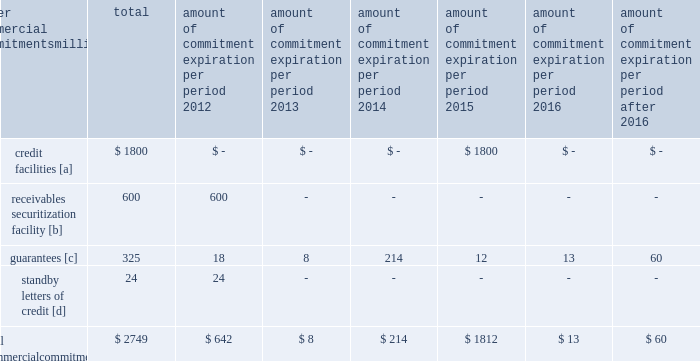Amount of commitment expiration per period other commercial commitments after millions total 2012 2013 2014 2015 2016 2016 .
[a] none of the credit facility was used as of december 31 , 2011 .
[b] $ 100 million of the receivables securitization facility was utilized at december 31 , 2011 , which is accounted for as debt .
The full program matures in august 2012 .
[c] includes guaranteed obligations related to our headquarters building , equipment financings , and affiliated operations .
[d] none of the letters of credit were drawn upon as of december 31 , 2011 .
Off-balance sheet arrangements guarantees 2013 at december 31 , 2011 , we were contingently liable for $ 325 million in guarantees .
We have recorded a liability of $ 3 million for the fair value of these obligations as of december 31 , 2011 and 2010 .
We entered into these contingent guarantees in the normal course of business , and they include guaranteed obligations related to our headquarters building , equipment financings , and affiliated operations .
The final guarantee expires in 2022 .
We are not aware of any existing event of default that would require us to satisfy these guarantees .
We do not expect that these guarantees will have a material adverse effect on our consolidated financial condition , results of operations , or liquidity .
Other matters labor agreements 2013 in january 2010 , the nation 2019s largest freight railroads began the current round of negotiations with the labor unions .
Generally , contract negotiations with the various unions take place over an extended period of time .
This round of negotiations was no exception .
In september 2011 , the rail industry reached agreements with the united transportation union .
On november 5 , 2011 , a presidential emergency board ( peb ) appointed by president obama issued recommendations to resolve the disputes between the u.s .
Railroads and 11 unions that had not yet reached agreements .
Since then , ten unions reached agreements with the railroads , all of them generally patterned on the recommendations of the peb , and the unions subsequently ratified these agreements .
The railroad industry reached a tentative agreement with the brotherhood of maintenance of way employees ( bmwe ) on february 2 , 2012 , eliminating the immediate threat of a national rail strike .
The bmwe now will commence ratification of this tentative agreement by its members .
Inflation 2013 long periods of inflation significantly increase asset replacement costs for capital-intensive companies .
As a result , assuming that we replace all operating assets at current price levels , depreciation charges ( on an inflation-adjusted basis ) would be substantially greater than historically reported amounts .
Derivative financial instruments 2013 we may use derivative financial instruments in limited instances to assist in managing our overall exposure to fluctuations in interest rates and fuel prices .
We are not a party to leveraged derivatives and , by policy , do not use derivative financial instruments for speculative purposes .
Derivative financial instruments qualifying for hedge accounting must maintain a specified level of effectiveness between the hedging instrument and the item being hedged , both at inception and throughout the hedged period .
We formally document the nature and relationships between the hedging instruments and hedged items at inception , as well as our risk-management objectives , strategies for undertaking the various hedge transactions , and method of assessing hedge effectiveness .
Changes in the fair market value of derivative financial instruments that do not qualify for hedge accounting are charged to earnings .
We may use swaps , collars , futures , and/or forward contracts to mitigate the risk of adverse movements in interest rates and fuel prices ; however , the use of these derivative financial instruments may limit future benefits from favorable price movements. .
What percent of total commercial commitments are receivables securitization facility? 
Computations: (600 / 2749)
Answer: 0.21826. 